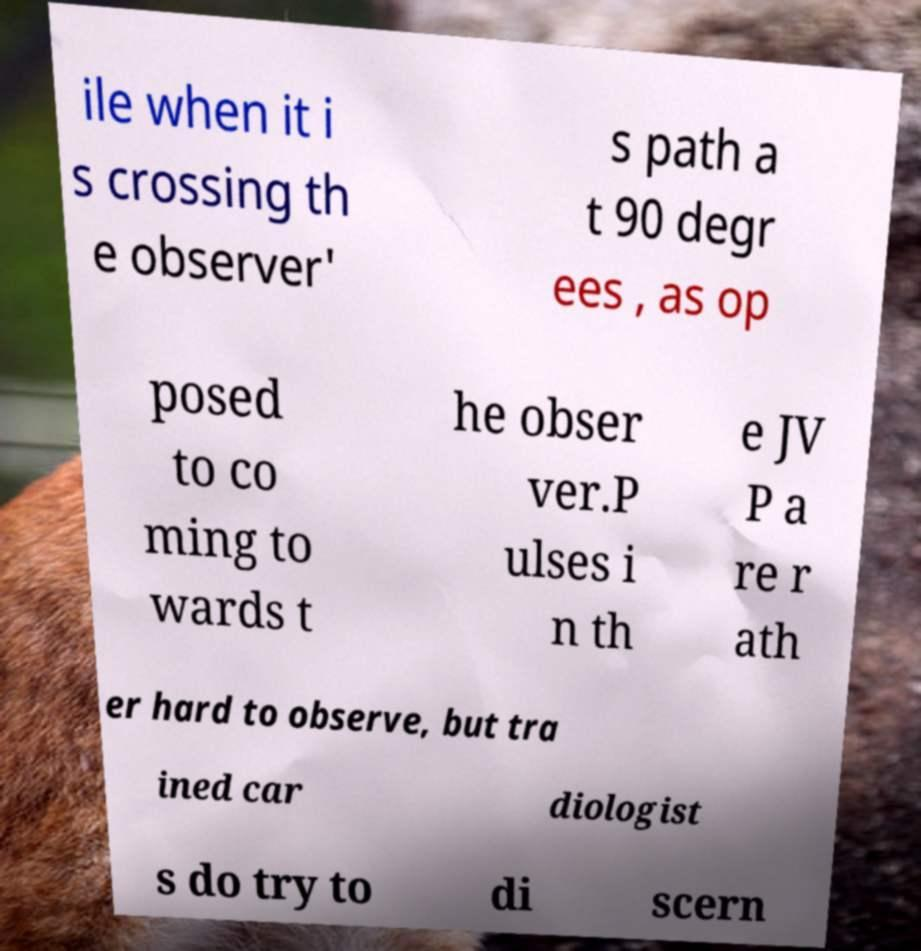What messages or text are displayed in this image? I need them in a readable, typed format. ile when it i s crossing th e observer' s path a t 90 degr ees , as op posed to co ming to wards t he obser ver.P ulses i n th e JV P a re r ath er hard to observe, but tra ined car diologist s do try to di scern 